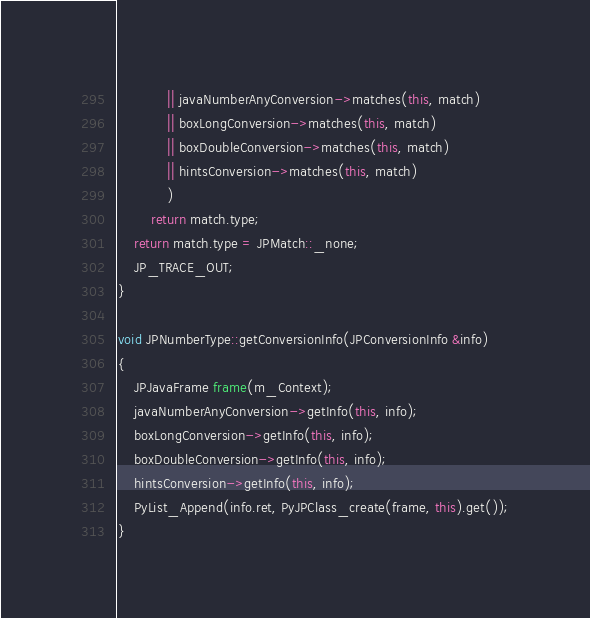Convert code to text. <code><loc_0><loc_0><loc_500><loc_500><_C++_>			|| javaNumberAnyConversion->matches(this, match)
			|| boxLongConversion->matches(this, match)
			|| boxDoubleConversion->matches(this, match)
			|| hintsConversion->matches(this, match)
			)
		return match.type;
	return match.type = JPMatch::_none;
	JP_TRACE_OUT;
}

void JPNumberType::getConversionInfo(JPConversionInfo &info)
{
	JPJavaFrame frame(m_Context);
	javaNumberAnyConversion->getInfo(this, info);
	boxLongConversion->getInfo(this, info);
	boxDoubleConversion->getInfo(this, info);
	hintsConversion->getInfo(this, info);
	PyList_Append(info.ret, PyJPClass_create(frame, this).get());
}</code> 